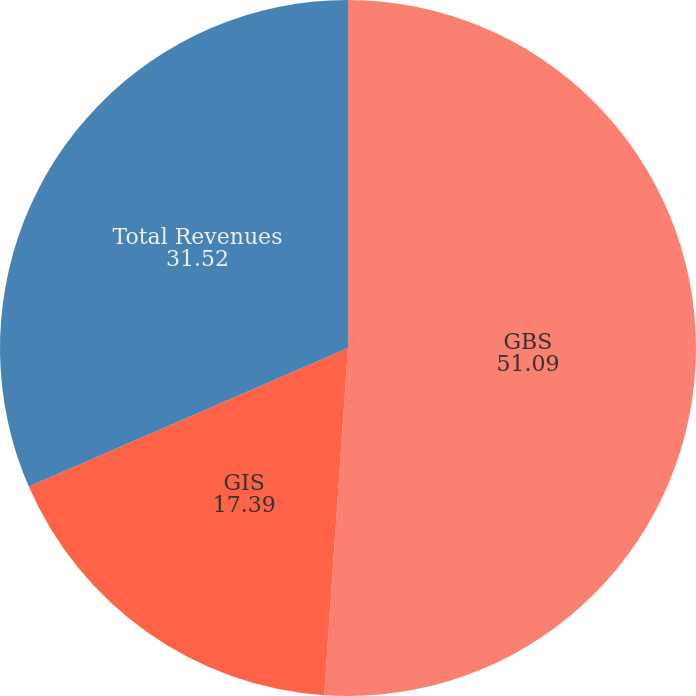Convert chart to OTSL. <chart><loc_0><loc_0><loc_500><loc_500><pie_chart><fcel>GBS<fcel>GIS<fcel>Total Revenues<nl><fcel>51.09%<fcel>17.39%<fcel>31.52%<nl></chart> 